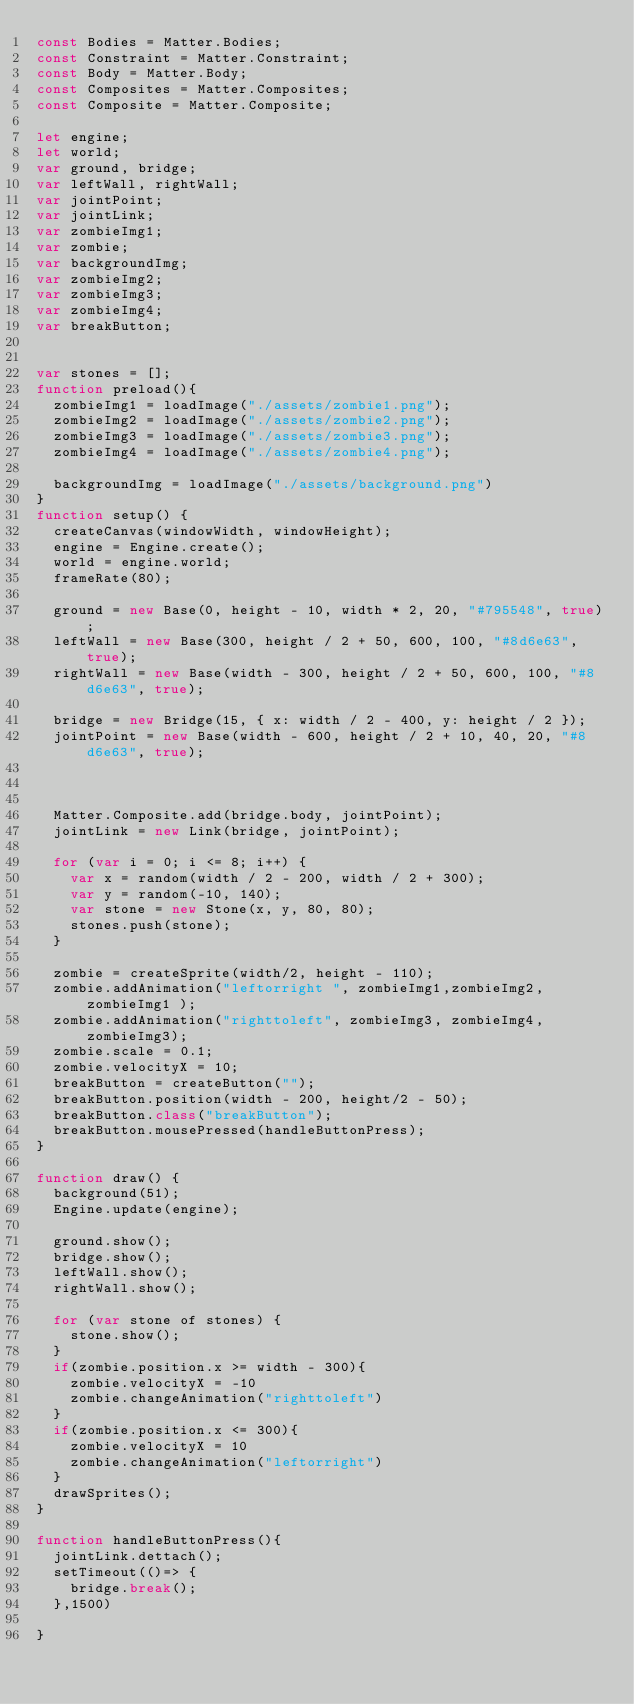Convert code to text. <code><loc_0><loc_0><loc_500><loc_500><_JavaScript_>const Bodies = Matter.Bodies;
const Constraint = Matter.Constraint;
const Body = Matter.Body;
const Composites = Matter.Composites;
const Composite = Matter.Composite;

let engine;
let world;
var ground, bridge;
var leftWall, rightWall;
var jointPoint;
var jointLink;
var zombieImg1;
var zombie;
var backgroundImg;
var zombieImg2;
var zombieImg3;
var zombieImg4;
var breakButton;


var stones = [];
function preload(){
  zombieImg1 = loadImage("./assets/zombie1.png");
  zombieImg2 = loadImage("./assets/zombie2.png");
  zombieImg3 = loadImage("./assets/zombie3.png");
  zombieImg4 = loadImage("./assets/zombie4.png");

  backgroundImg = loadImage("./assets/background.png")
}
function setup() {
  createCanvas(windowWidth, windowHeight);
  engine = Engine.create();
  world = engine.world;
  frameRate(80);

  ground = new Base(0, height - 10, width * 2, 20, "#795548", true);
  leftWall = new Base(300, height / 2 + 50, 600, 100, "#8d6e63", true);
  rightWall = new Base(width - 300, height / 2 + 50, 600, 100, "#8d6e63", true);

  bridge = new Bridge(15, { x: width / 2 - 400, y: height / 2 });
  jointPoint = new Base(width - 600, height / 2 + 10, 40, 20, "#8d6e63", true);



  Matter.Composite.add(bridge.body, jointPoint);
  jointLink = new Link(bridge, jointPoint);

  for (var i = 0; i <= 8; i++) {
    var x = random(width / 2 - 200, width / 2 + 300);
    var y = random(-10, 140);
    var stone = new Stone(x, y, 80, 80);
    stones.push(stone);
  }

  zombie = createSprite(width/2, height - 110);
  zombie.addAnimation("leftorright ", zombieImg1,zombieImg2, zombieImg1 );
  zombie.addAnimation("righttoleft", zombieImg3, zombieImg4, zombieImg3);
  zombie.scale = 0.1;
  zombie.velocityX = 10;
  breakButton = createButton("");
  breakButton.position(width - 200, height/2 - 50);
  breakButton.class("breakButton");
  breakButton.mousePressed(handleButtonPress);
}

function draw() {
  background(51);
  Engine.update(engine);

  ground.show();
  bridge.show();
  leftWall.show();
  rightWall.show();

  for (var stone of stones) {
    stone.show();
  }
  if(zombie.position.x >= width - 300){
    zombie.velocityX = -10
    zombie.changeAnimation("righttoleft")
  }
  if(zombie.position.x <= 300){
    zombie.velocityX = 10
    zombie.changeAnimation("leftorright")
  }
  drawSprites();
}

function handleButtonPress(){
  jointLink.dettach();
  setTimeout(()=> {
    bridge.break();
  },1500)

}


</code> 